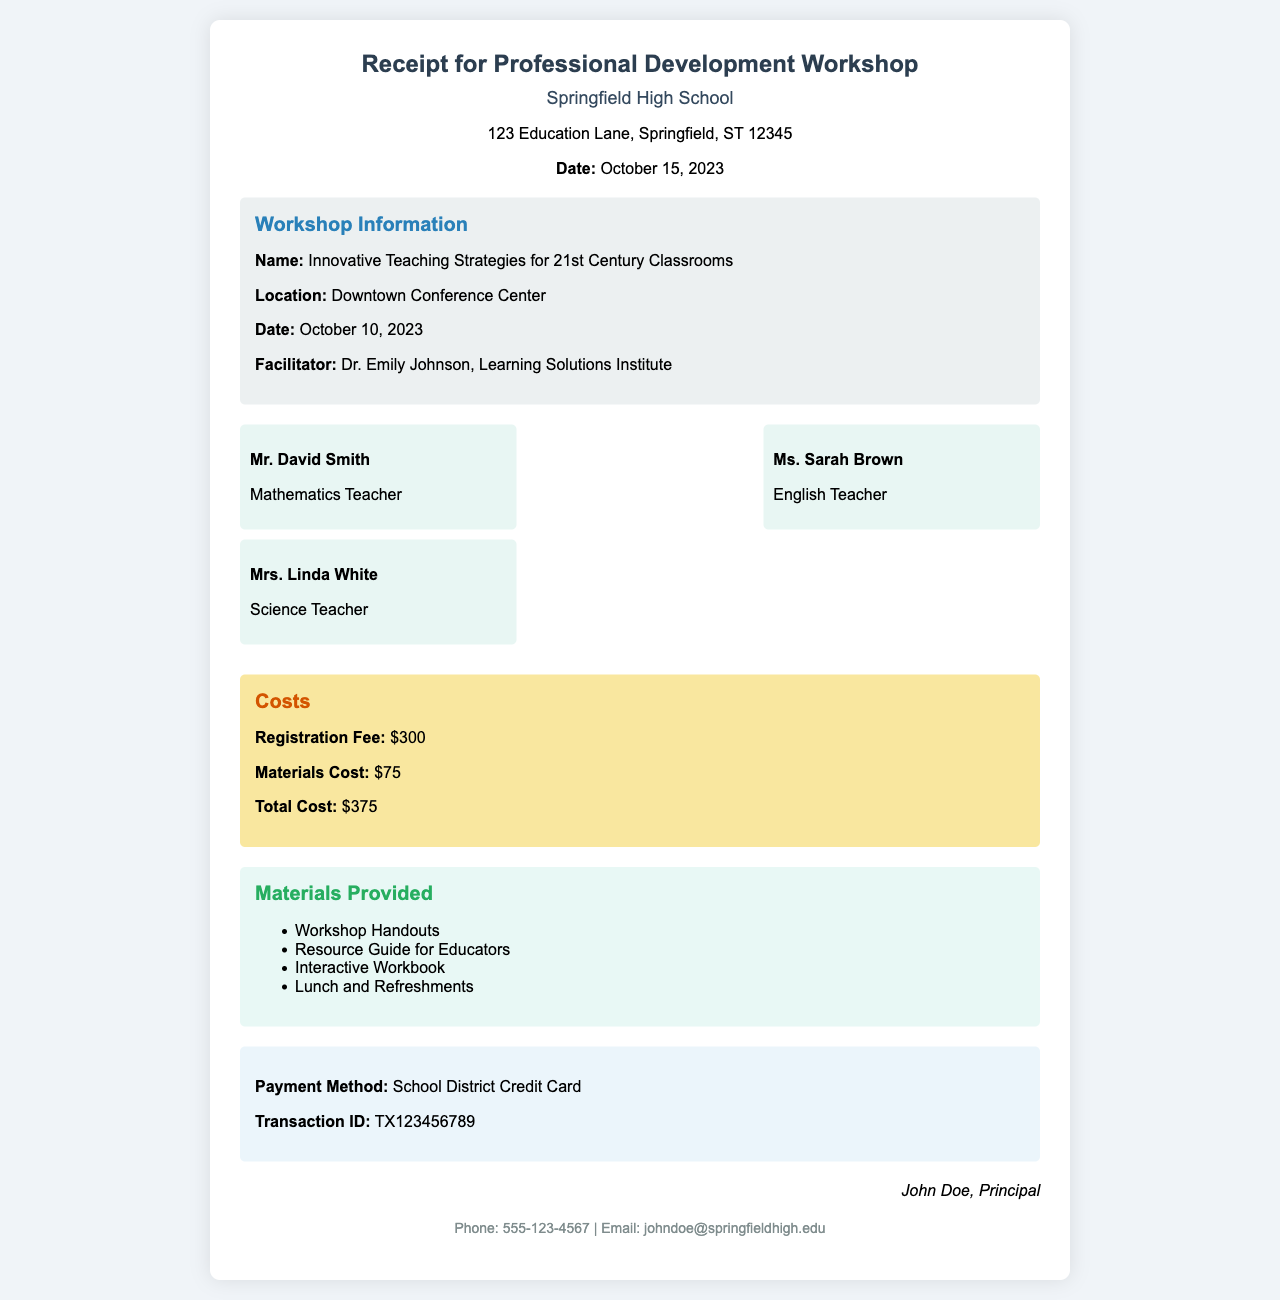What is the name of the workshop? The name of the workshop is clearly stated in the document, which is "Innovative Teaching Strategies for 21st Century Classrooms."
Answer: Innovative Teaching Strategies for 21st Century Classrooms Who is the facilitator of the workshop? The document mentions the facilitator's name, which is Dr. Emily Johnson.
Answer: Dr. Emily Johnson What is the total cost for attending the workshop? The total cost is provided in the costs section, which sums the registration fee and materials cost.
Answer: $375 How many teachers attended the workshop? The document lists three participants who attended the workshop.
Answer: Three What materials were provided during the workshop? The document includes a list of materials provided, specifying items such as workshop handouts and interactive workbooks.
Answer: Workshop Handouts, Resource Guide for Educators, Interactive Workbook, Lunch and Refreshments What payment method was used? The payment method is described in the payment section, specifically mentioning the use of a school district credit card.
Answer: School District Credit Card What date was the workshop held? The date of the workshop is stated in the workshop details section, indicating when it took place.
Answer: October 10, 2023 What is the transaction ID for the payment? The transaction ID is provided in the payment section of the document for reference.
Answer: TX123456789 